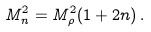Convert formula to latex. <formula><loc_0><loc_0><loc_500><loc_500>M _ { n } ^ { 2 } = M _ { \rho } ^ { 2 } ( 1 + 2 n ) \, .</formula> 